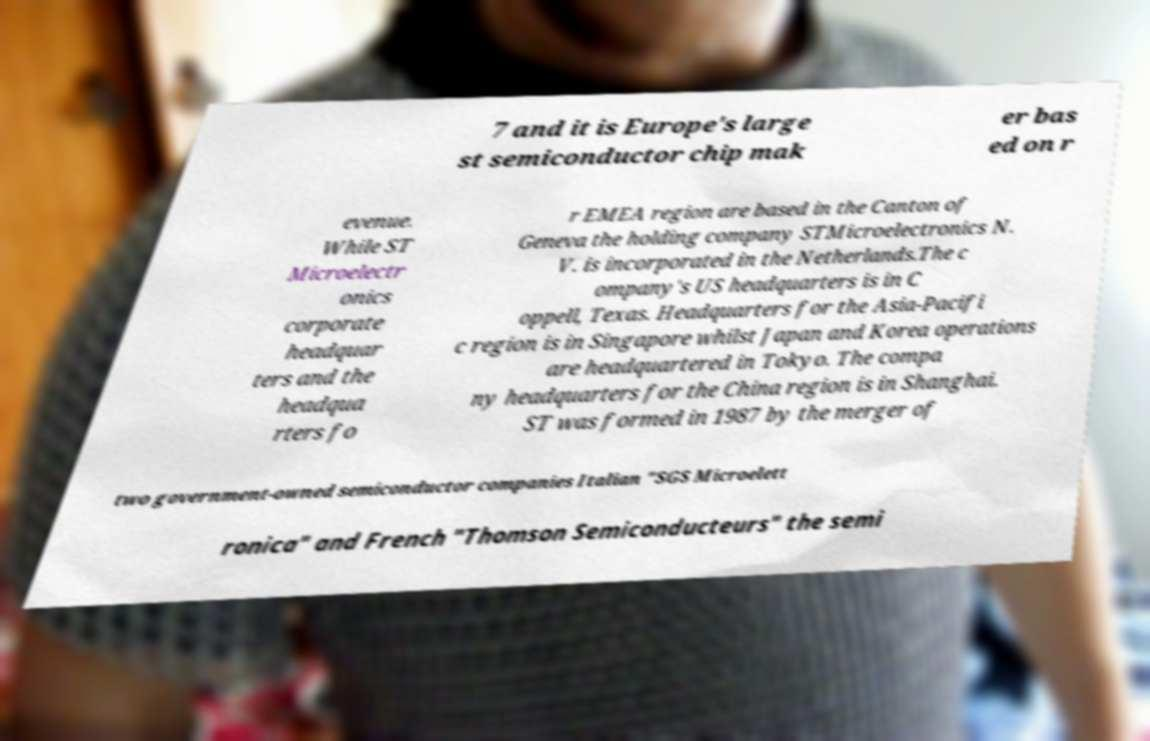Please read and relay the text visible in this image. What does it say? 7 and it is Europe's large st semiconductor chip mak er bas ed on r evenue. While ST Microelectr onics corporate headquar ters and the headqua rters fo r EMEA region are based in the Canton of Geneva the holding company STMicroelectronics N. V. is incorporated in the Netherlands.The c ompany's US headquarters is in C oppell, Texas. Headquarters for the Asia-Pacifi c region is in Singapore whilst Japan and Korea operations are headquartered in Tokyo. The compa ny headquarters for the China region is in Shanghai. ST was formed in 1987 by the merger of two government-owned semiconductor companies Italian "SGS Microelett ronica" and French "Thomson Semiconducteurs" the semi 